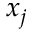<formula> <loc_0><loc_0><loc_500><loc_500>x _ { j }</formula> 